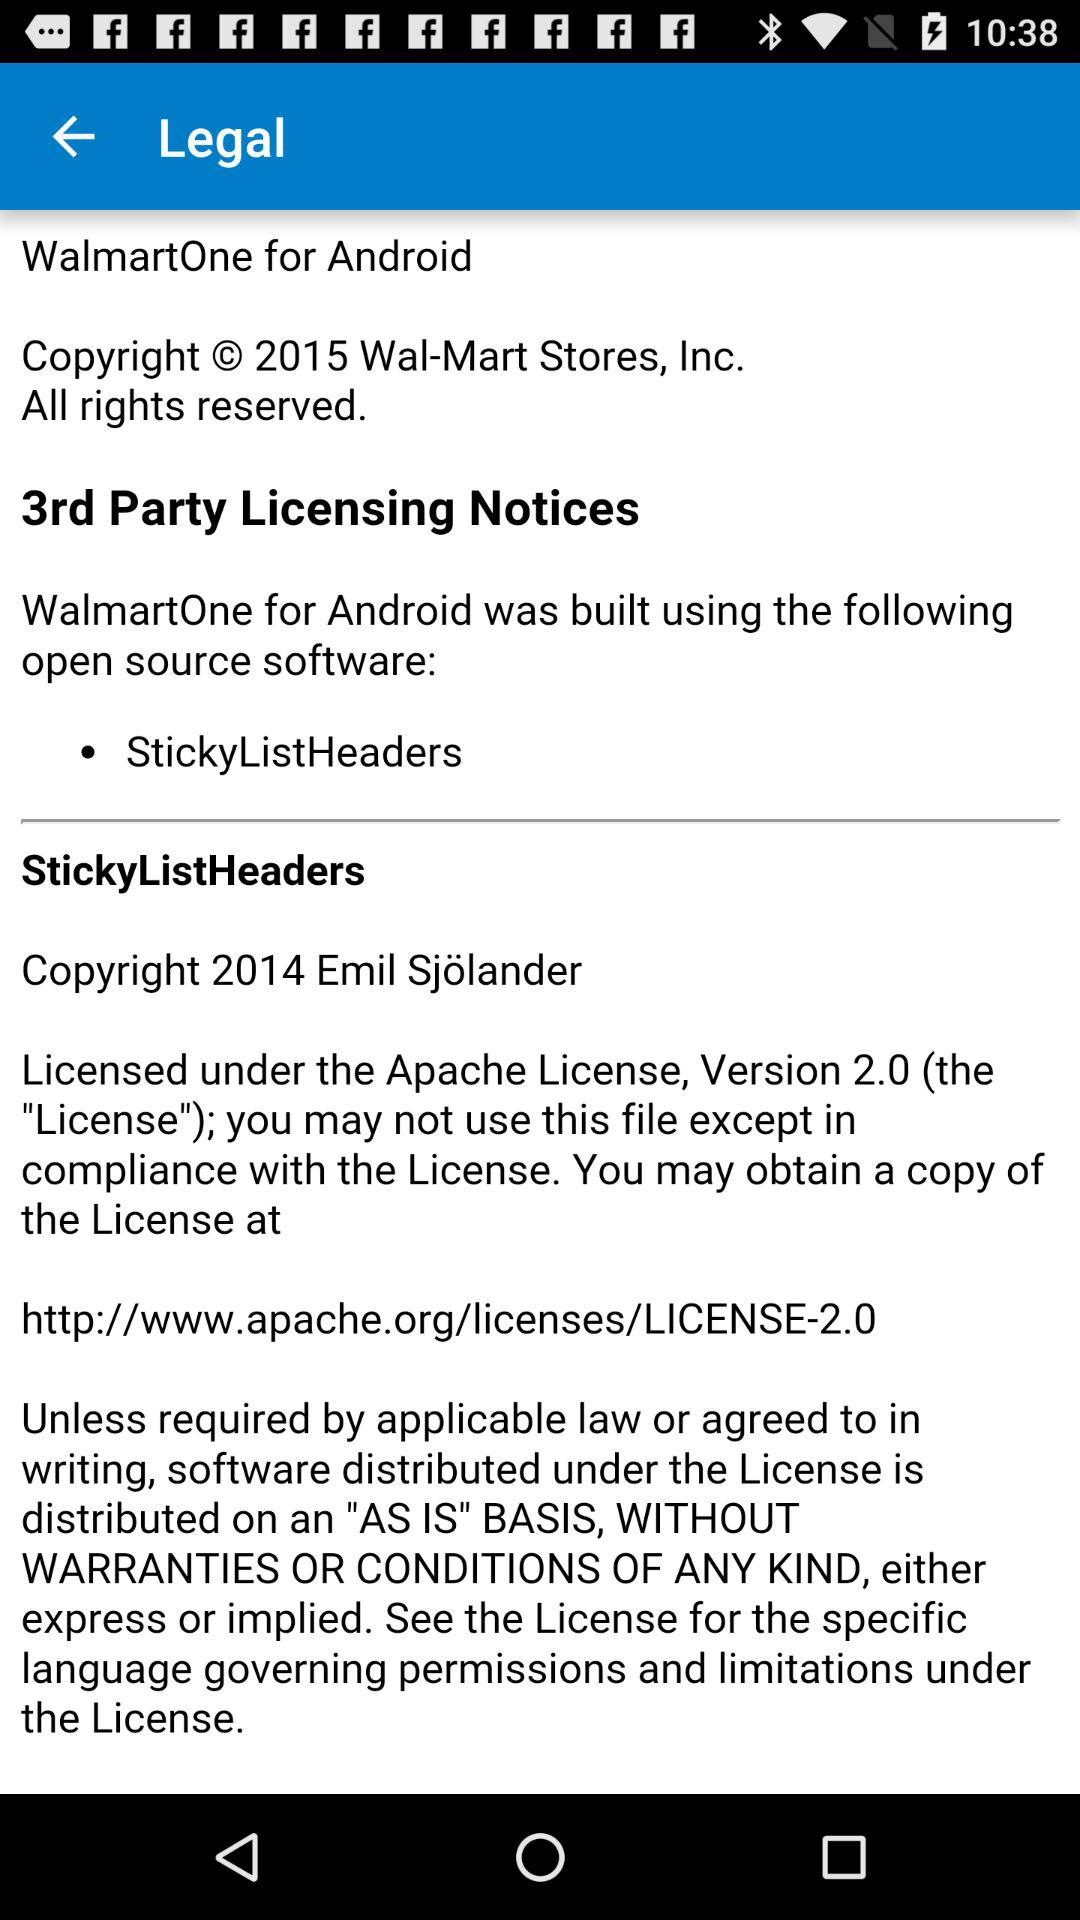How many copyright notices are there on the screen?
Answer the question using a single word or phrase. 2 